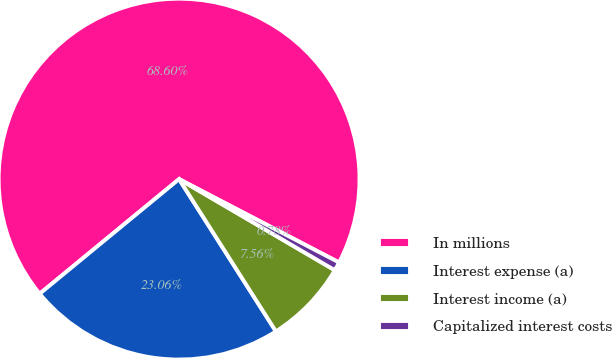Convert chart. <chart><loc_0><loc_0><loc_500><loc_500><pie_chart><fcel>In millions<fcel>Interest expense (a)<fcel>Interest income (a)<fcel>Capitalized interest costs<nl><fcel>68.59%<fcel>23.06%<fcel>7.56%<fcel>0.78%<nl></chart> 